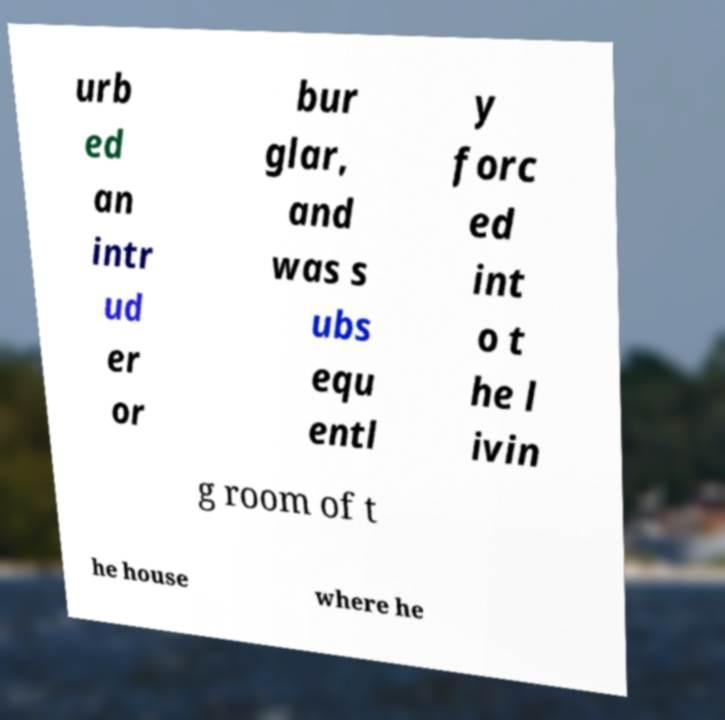Could you extract and type out the text from this image? urb ed an intr ud er or bur glar, and was s ubs equ entl y forc ed int o t he l ivin g room of t he house where he 